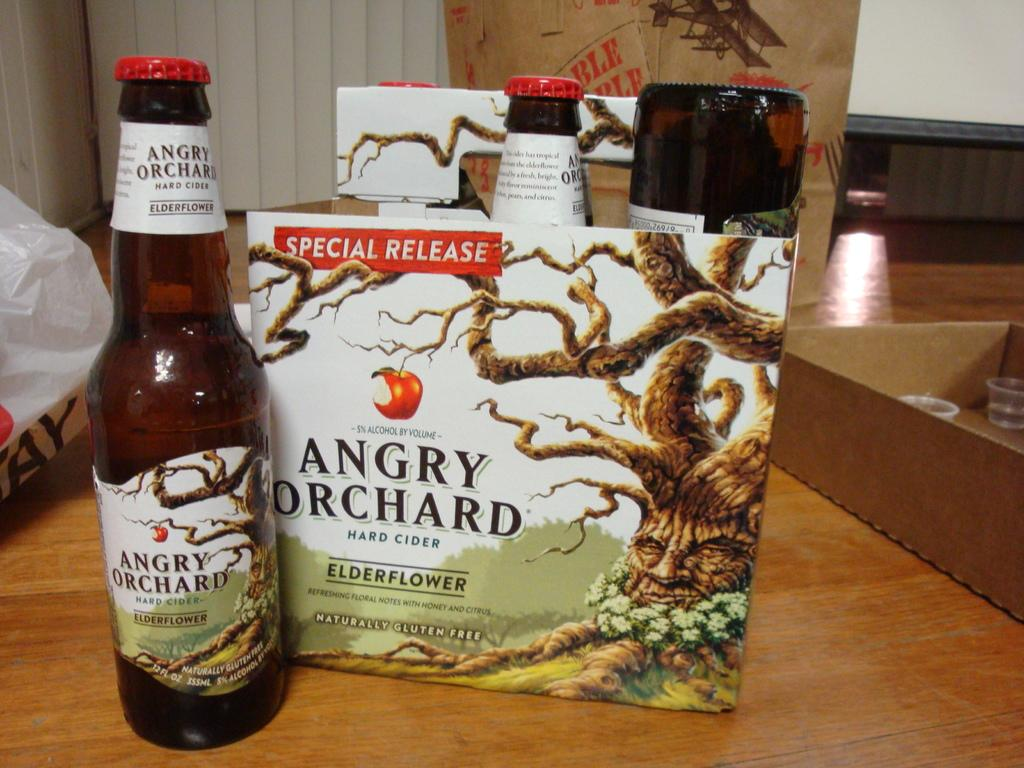<image>
Offer a succinct explanation of the picture presented. A carton of bottles from Angry Orchard sit on wooden table. 